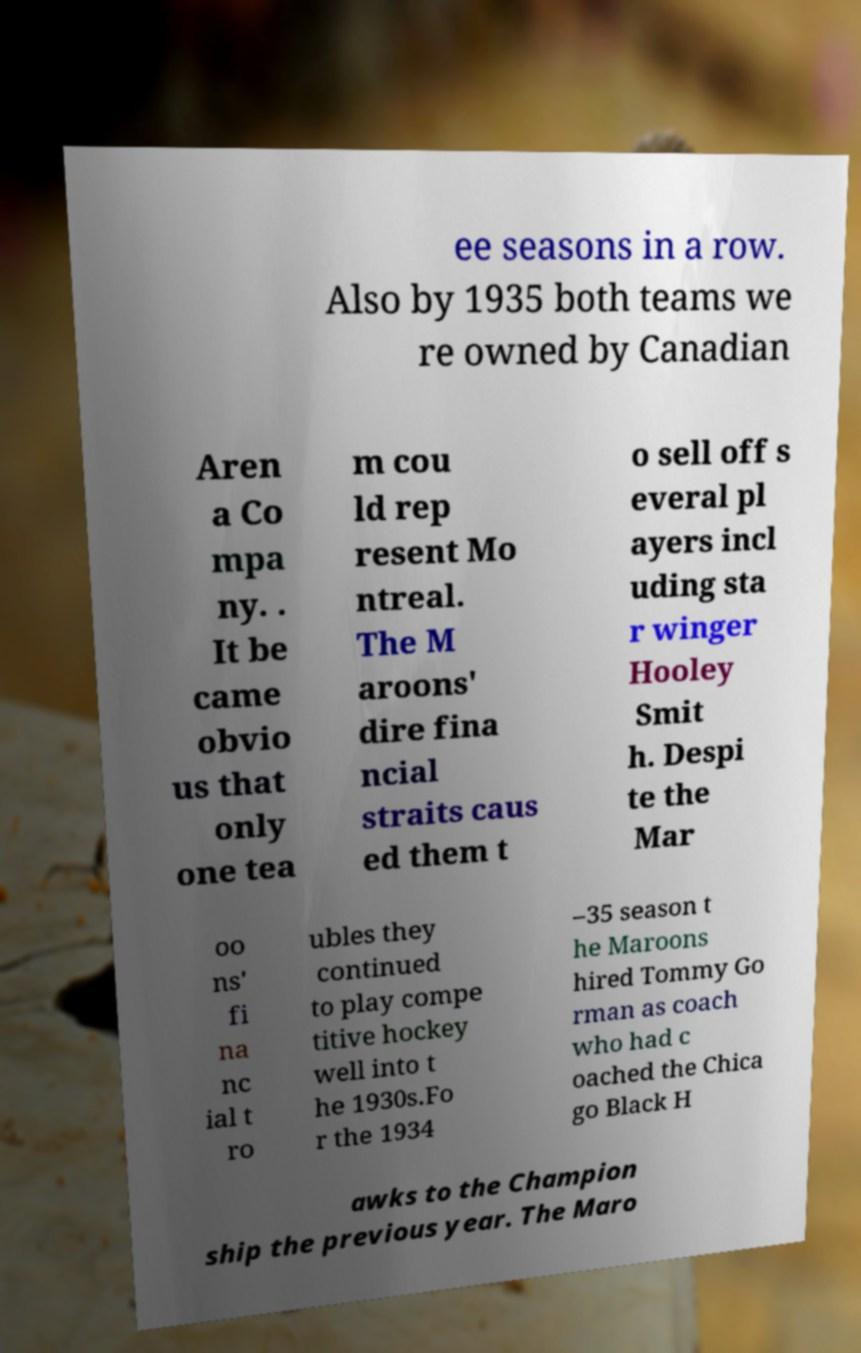What messages or text are displayed in this image? I need them in a readable, typed format. ee seasons in a row. Also by 1935 both teams we re owned by Canadian Aren a Co mpa ny. . It be came obvio us that only one tea m cou ld rep resent Mo ntreal. The M aroons' dire fina ncial straits caus ed them t o sell off s everal pl ayers incl uding sta r winger Hooley Smit h. Despi te the Mar oo ns' fi na nc ial t ro ubles they continued to play compe titive hockey well into t he 1930s.Fo r the 1934 –35 season t he Maroons hired Tommy Go rman as coach who had c oached the Chica go Black H awks to the Champion ship the previous year. The Maro 